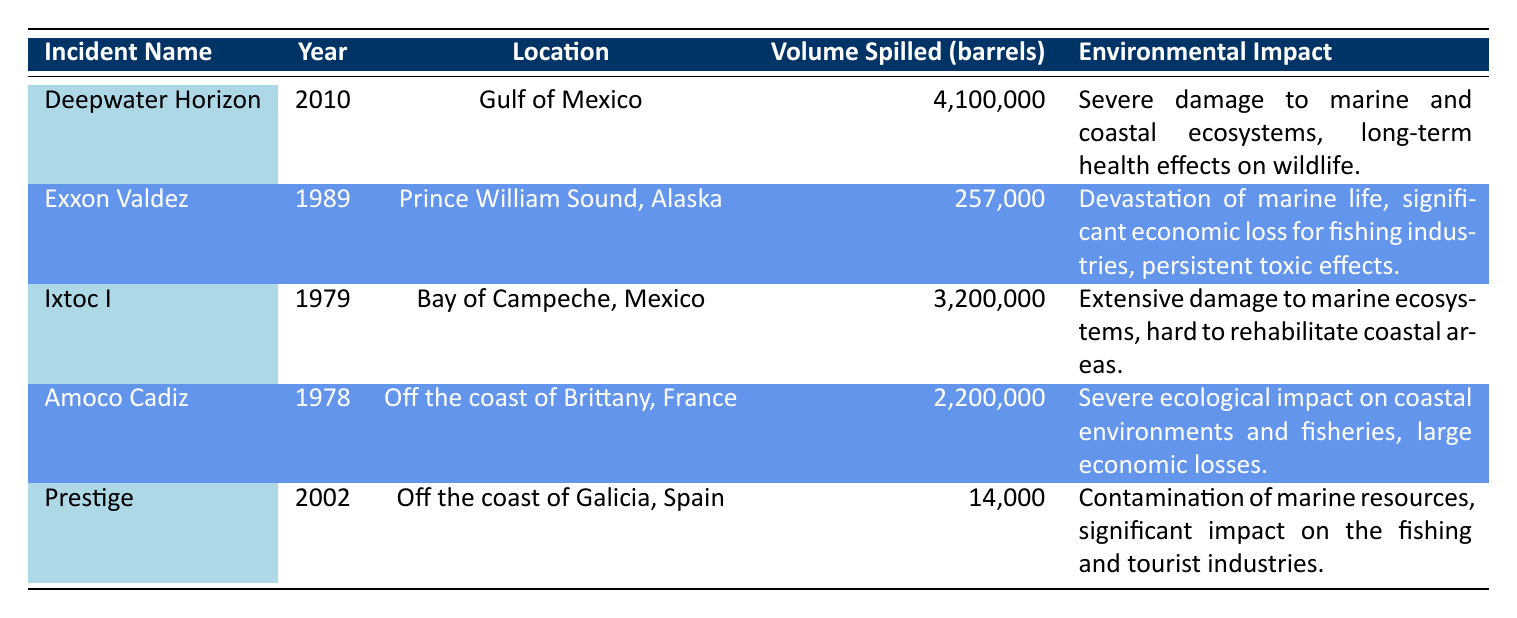What was the volume of oil spilled in the Deepwater Horizon incident? The table lists the volume of oil spilled in each incident, and for the Deepwater Horizon incident, it is specifically noted as 4,100,000 barrels.
Answer: 4,100,000 barrels Which incident resulted in the smallest volume of oil spilled? Looking through the table, the incident with the smallest volume of oil spilled is the Prestige, with 14,000 barrels.
Answer: Prestige: 14,000 barrels Is the environmental impact of the Exxon Valdez incident described as severe? The table states that the environmental impact of the Exxon Valdez incident includes "Devastation of marine life," but does not specifically label it as "severe."
Answer: No How many barrels were spilled in incidents that occurred in the 2000s? The only incident listed in the 2000s is Deepwater Horizon, which spilled 4,100,000 barrels, and Prestige is from 2002, which spilled 14,000 barrels. Summing these gives 4,100,000 + 14,000 = 4,114,000 barrels.
Answer: 4,114,000 barrels What was the average volume of oil spilled across all incidents listed? To find the average, first sum the spilled volumes: 4,100,000 + 257,000 + 3,200,000 + 2,200,000 + 14,000 = 9,771,000 barrels. There are 5 incidents, so the average is 9,771,000 / 5 = 1,954,200 barrels.
Answer: 1,954,200 barrels Does the Ixtoc I incident involve a location outside of the United States? The table shows that Ixtoc I occurred in the Bay of Campeche, Mexico, which is not in the United States.
Answer: Yes What incident caused severe damage to marine and coastal ecosystems? Referring to the environmental impact column, the Deepwater Horizon incident is noted for "Severe damage to marine and coastal ecosystems."
Answer: Deepwater Horizon How many incidents mentioned had a significant impact on fishing industries? The table describes the Exxon Valdez incident as having a "significant economic loss for fishing industries" and the Prestige incident as having a "significant impact on the fishing and tourist industries." That totals two incidents.
Answer: 2 incidents 